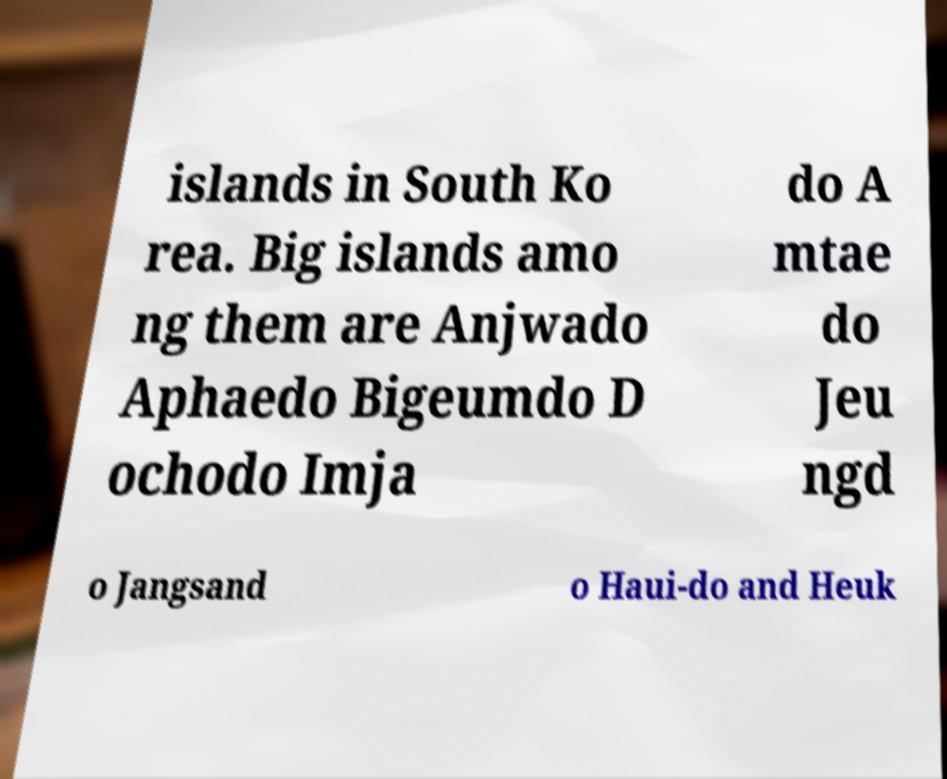Could you assist in decoding the text presented in this image and type it out clearly? islands in South Ko rea. Big islands amo ng them are Anjwado Aphaedo Bigeumdo D ochodo Imja do A mtae do Jeu ngd o Jangsand o Haui-do and Heuk 